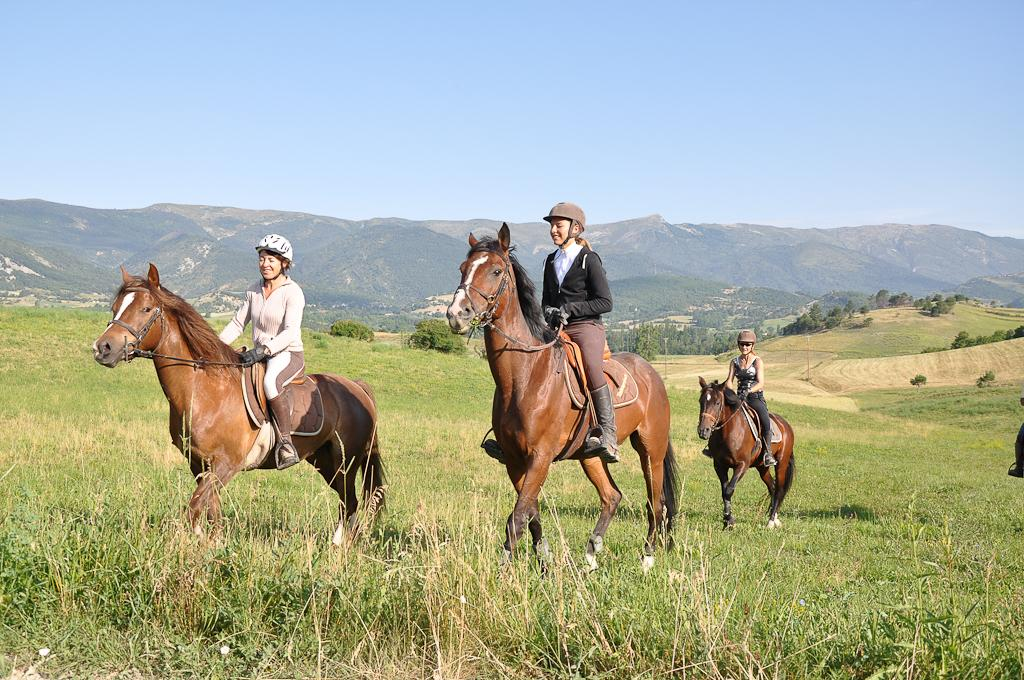What are the women in the image doing? The women in the image are riding horses. What are the women wearing on their heads? The women are wearing caps on their heads. What type of terrain can be seen in the image? There is grass, trees, and hills visible in the image. How would you describe the sky in the image? The sky is blue and cloudy. Can you see any bananas being used as support for the horses in the image? There are no bananas present in the image, and they are not being used as support for the horses. How many frogs can be seen riding alongside the women in the image? There are no frogs present in the image; only the women riding horses can be seen. 